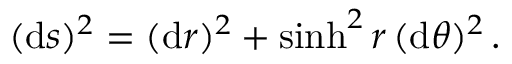<formula> <loc_0><loc_0><loc_500><loc_500>( d s ) ^ { 2 } = ( d r ) ^ { 2 } + \sinh ^ { 2 } r \, ( d \theta ) ^ { 2 } \, .</formula> 